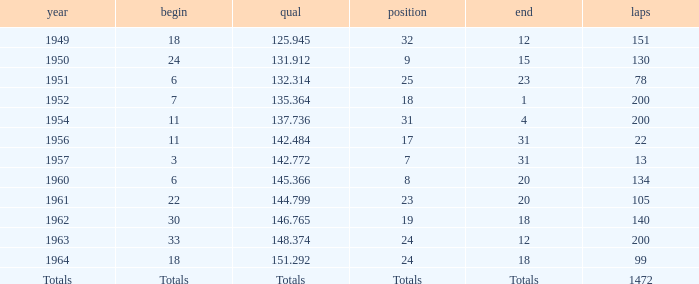Name the rank with finish of 12 and year of 1963 24.0. 